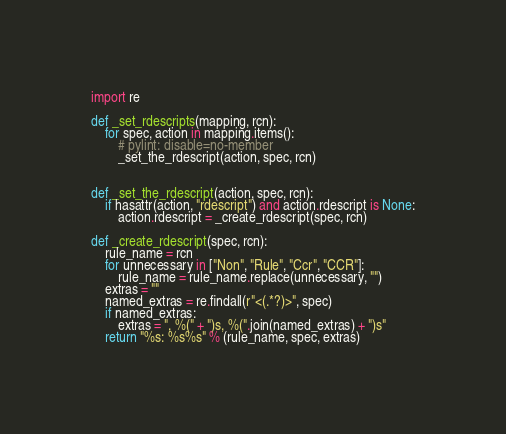Convert code to text. <code><loc_0><loc_0><loc_500><loc_500><_Python_>import re

def _set_rdescripts(mapping, rcn):
    for spec, action in mapping.items():
        # pylint: disable=no-member
        _set_the_rdescript(action, spec, rcn)


def _set_the_rdescript(action, spec, rcn):
    if hasattr(action, "rdescript") and action.rdescript is None:
        action.rdescript = _create_rdescript(spec, rcn)

def _create_rdescript(spec, rcn):
    rule_name = rcn
    for unnecessary in ["Non", "Rule", "Ccr", "CCR"]:
        rule_name = rule_name.replace(unnecessary, "")
    extras = ""
    named_extras = re.findall(r"<(.*?)>", spec)
    if named_extras:
        extras = ", %(" + ")s, %(".join(named_extras) + ")s"
    return "%s: %s%s" % (rule_name, spec, extras)
</code> 